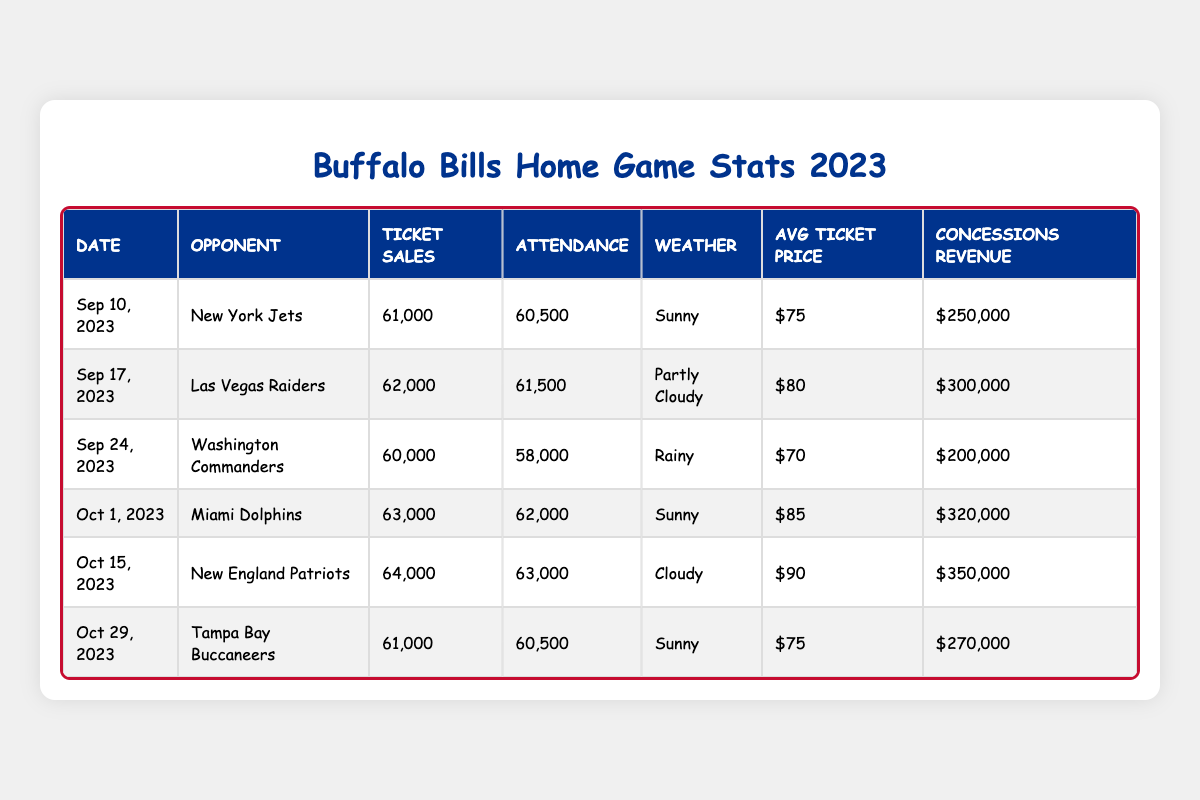What is the total attendance for the home games listed? To find the total attendance, I will add the attendance figures for each game: 60500 + 61500 + 58000 + 62000 + 63000 + 60500 = 375000.
Answer: 375000 Which game had the highest ticket sales? Looking at the ticket sales column, the highest figure is 64000 for the game against the New England Patriots on October 15, 2023.
Answer: New England Patriots What was the average ticket price for the home games? To calculate the average ticket price, I will add the ticket prices: (75 + 80 + 70 + 85 + 90 + 75) = 475, and then divide by the number of games (6): 475/6 = 79.17.
Answer: 79.17 Did the Buffalo Bills sell more than 61000 tickets in all the games? I will check each ticket sales value: 61000, 62000, 60000, 63000, 64000, and 61000. The games against Washington Commanders sold less than 61000 tickets, so the statement is false.
Answer: No What was the total concessions revenue across all home games? I will sum up all the concessions revenues: 250000 + 300000 + 200000 + 320000 + 350000 + 270000 = 1690000.
Answer: 1690000 Which weather condition was associated with the lowest attendance? The lowest attendance is 58000 for the game against the Washington Commanders, which was rainy.
Answer: Rainy What is the difference in ticket sales between the game against the Miami Dolphins and the game against the New York Jets? The ticket sales for the Dolphins game is 63000 and for the Jets game is 61000. The difference is 63000 - 61000 = 2000.
Answer: 2000 Which game had the highest concessions revenue? The highest concessions revenue is 350000 for the game against the New England Patriots on October 15, 2023.
Answer: New England Patriots What percentage of ticket sales attended the game against the Las Vegas Raiders? The attendance for the Raiders game is 61500, and the ticket sales were 62000. The percentage is (61500/62000) * 100 = 99.19%.
Answer: 99.19% How does the average ticket price for sunny weather games compare to those with rainy weather? The average ticket price for sunny games (75 + 85 + 75) is (75 + 85 + 75)/3 = 78.33. For rainy weather, there's only one game with a price of 70. Comparing these averages, 78.33 > 70.
Answer: Sunny weather games are higher 